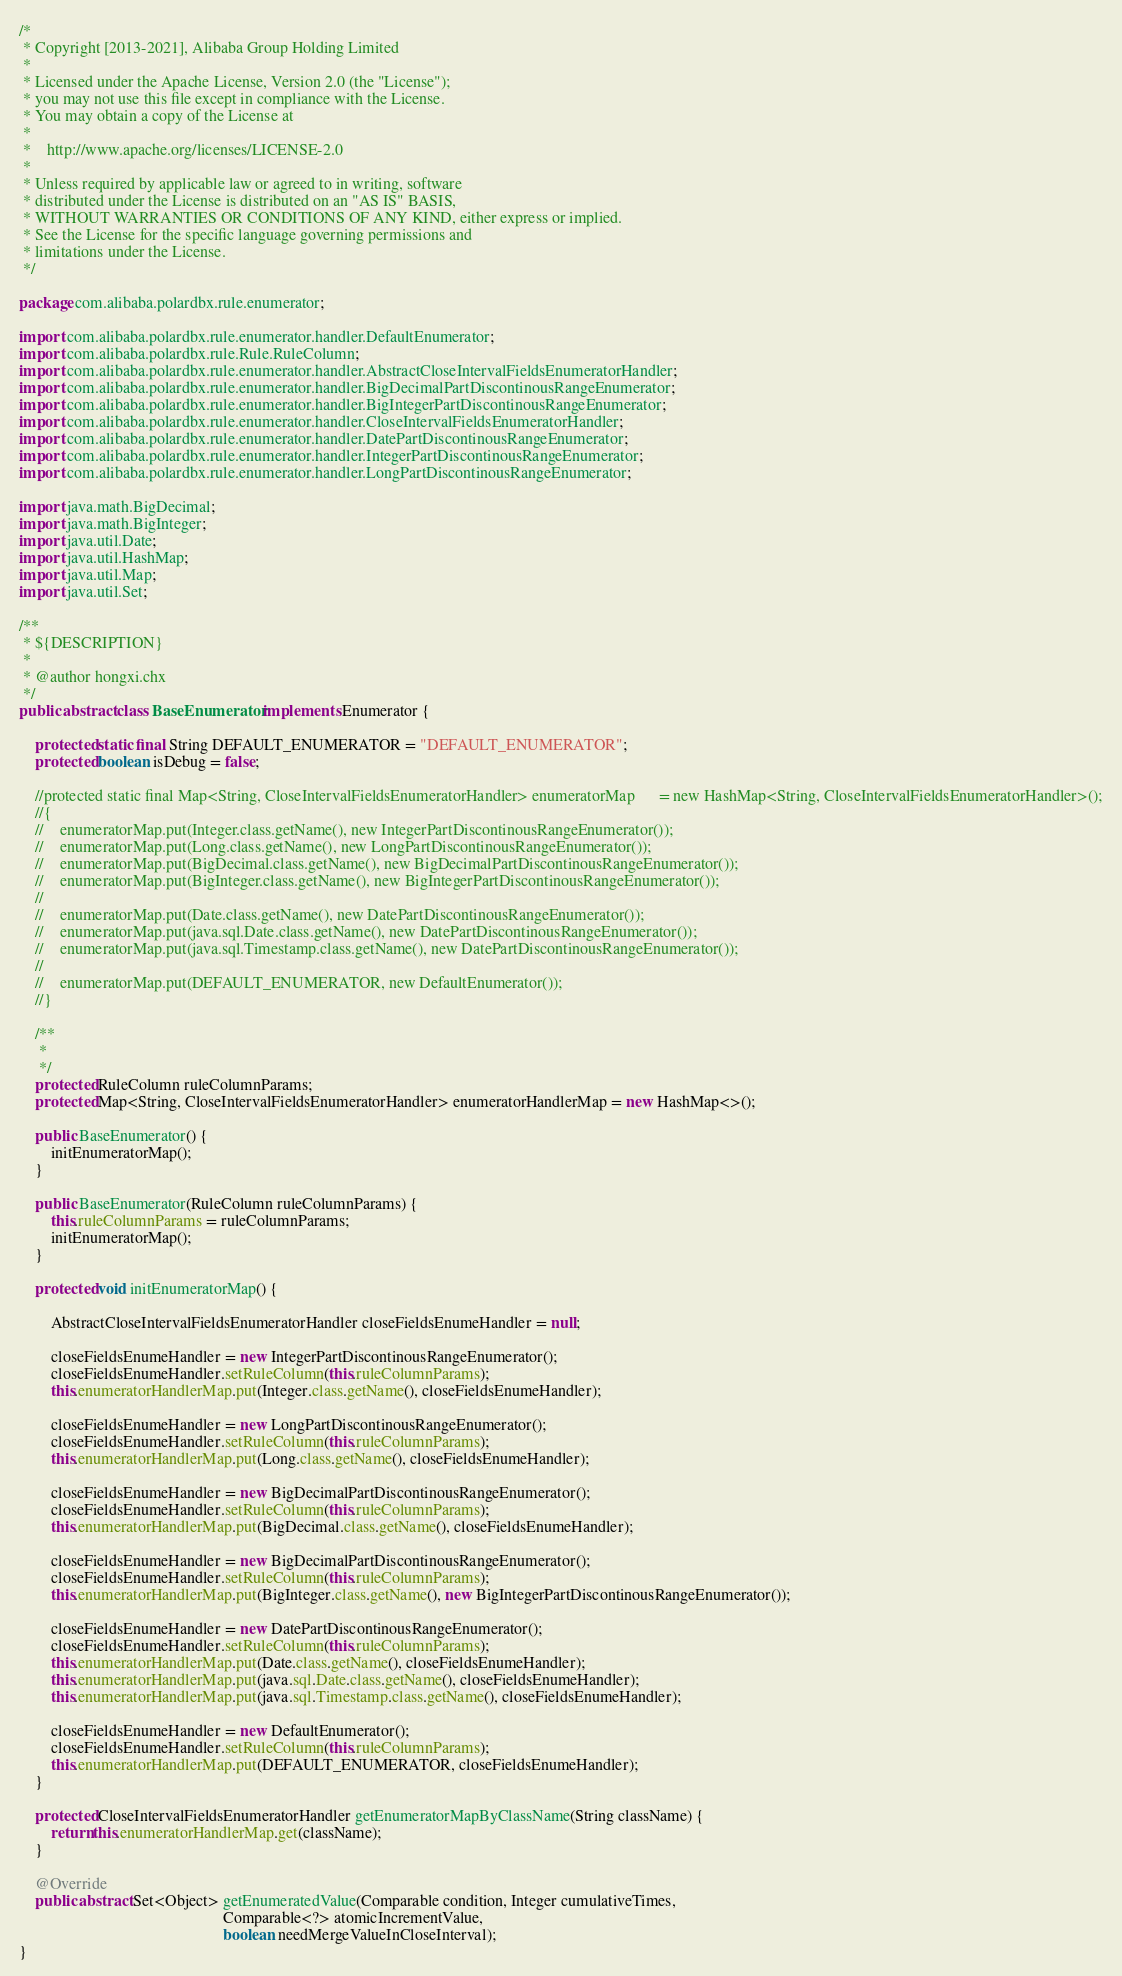Convert code to text. <code><loc_0><loc_0><loc_500><loc_500><_Java_>/*
 * Copyright [2013-2021], Alibaba Group Holding Limited
 *
 * Licensed under the Apache License, Version 2.0 (the "License");
 * you may not use this file except in compliance with the License.
 * You may obtain a copy of the License at
 *
 *    http://www.apache.org/licenses/LICENSE-2.0
 *
 * Unless required by applicable law or agreed to in writing, software
 * distributed under the License is distributed on an "AS IS" BASIS,
 * WITHOUT WARRANTIES OR CONDITIONS OF ANY KIND, either express or implied.
 * See the License for the specific language governing permissions and
 * limitations under the License.
 */

package com.alibaba.polardbx.rule.enumerator;

import com.alibaba.polardbx.rule.enumerator.handler.DefaultEnumerator;
import com.alibaba.polardbx.rule.Rule.RuleColumn;
import com.alibaba.polardbx.rule.enumerator.handler.AbstractCloseIntervalFieldsEnumeratorHandler;
import com.alibaba.polardbx.rule.enumerator.handler.BigDecimalPartDiscontinousRangeEnumerator;
import com.alibaba.polardbx.rule.enumerator.handler.BigIntegerPartDiscontinousRangeEnumerator;
import com.alibaba.polardbx.rule.enumerator.handler.CloseIntervalFieldsEnumeratorHandler;
import com.alibaba.polardbx.rule.enumerator.handler.DatePartDiscontinousRangeEnumerator;
import com.alibaba.polardbx.rule.enumerator.handler.IntegerPartDiscontinousRangeEnumerator;
import com.alibaba.polardbx.rule.enumerator.handler.LongPartDiscontinousRangeEnumerator;

import java.math.BigDecimal;
import java.math.BigInteger;
import java.util.Date;
import java.util.HashMap;
import java.util.Map;
import java.util.Set;

/**
 * ${DESCRIPTION}
 *
 * @author hongxi.chx
 */
public abstract class BaseEnumerator implements Enumerator {

    protected static final String DEFAULT_ENUMERATOR = "DEFAULT_ENUMERATOR";
    protected boolean isDebug = false;

    //protected static final Map<String, CloseIntervalFieldsEnumeratorHandler> enumeratorMap      = new HashMap<String, CloseIntervalFieldsEnumeratorHandler>();
    //{
    //    enumeratorMap.put(Integer.class.getName(), new IntegerPartDiscontinousRangeEnumerator());
    //    enumeratorMap.put(Long.class.getName(), new LongPartDiscontinousRangeEnumerator());
    //    enumeratorMap.put(BigDecimal.class.getName(), new BigDecimalPartDiscontinousRangeEnumerator());
    //    enumeratorMap.put(BigInteger.class.getName(), new BigIntegerPartDiscontinousRangeEnumerator());
    //
    //    enumeratorMap.put(Date.class.getName(), new DatePartDiscontinousRangeEnumerator());
    //    enumeratorMap.put(java.sql.Date.class.getName(), new DatePartDiscontinousRangeEnumerator());
    //    enumeratorMap.put(java.sql.Timestamp.class.getName(), new DatePartDiscontinousRangeEnumerator());
    //
    //    enumeratorMap.put(DEFAULT_ENUMERATOR, new DefaultEnumerator());
    //}

    /**
     *
     */
    protected RuleColumn ruleColumnParams;
    protected Map<String, CloseIntervalFieldsEnumeratorHandler> enumeratorHandlerMap = new HashMap<>();

    public BaseEnumerator() {
        initEnumeratorMap();
    }

    public BaseEnumerator(RuleColumn ruleColumnParams) {
        this.ruleColumnParams = ruleColumnParams;
        initEnumeratorMap();
    }

    protected void initEnumeratorMap() {

        AbstractCloseIntervalFieldsEnumeratorHandler closeFieldsEnumeHandler = null;

        closeFieldsEnumeHandler = new IntegerPartDiscontinousRangeEnumerator();
        closeFieldsEnumeHandler.setRuleColumn(this.ruleColumnParams);
        this.enumeratorHandlerMap.put(Integer.class.getName(), closeFieldsEnumeHandler);

        closeFieldsEnumeHandler = new LongPartDiscontinousRangeEnumerator();
        closeFieldsEnumeHandler.setRuleColumn(this.ruleColumnParams);
        this.enumeratorHandlerMap.put(Long.class.getName(), closeFieldsEnumeHandler);

        closeFieldsEnumeHandler = new BigDecimalPartDiscontinousRangeEnumerator();
        closeFieldsEnumeHandler.setRuleColumn(this.ruleColumnParams);
        this.enumeratorHandlerMap.put(BigDecimal.class.getName(), closeFieldsEnumeHandler);

        closeFieldsEnumeHandler = new BigDecimalPartDiscontinousRangeEnumerator();
        closeFieldsEnumeHandler.setRuleColumn(this.ruleColumnParams);
        this.enumeratorHandlerMap.put(BigInteger.class.getName(), new BigIntegerPartDiscontinousRangeEnumerator());

        closeFieldsEnumeHandler = new DatePartDiscontinousRangeEnumerator();
        closeFieldsEnumeHandler.setRuleColumn(this.ruleColumnParams);
        this.enumeratorHandlerMap.put(Date.class.getName(), closeFieldsEnumeHandler);
        this.enumeratorHandlerMap.put(java.sql.Date.class.getName(), closeFieldsEnumeHandler);
        this.enumeratorHandlerMap.put(java.sql.Timestamp.class.getName(), closeFieldsEnumeHandler);

        closeFieldsEnumeHandler = new DefaultEnumerator();
        closeFieldsEnumeHandler.setRuleColumn(this.ruleColumnParams);
        this.enumeratorHandlerMap.put(DEFAULT_ENUMERATOR, closeFieldsEnumeHandler);
    }

    protected CloseIntervalFieldsEnumeratorHandler getEnumeratorMapByClassName(String className) {
        return this.enumeratorHandlerMap.get(className);
    }

    @Override
    public abstract Set<Object> getEnumeratedValue(Comparable condition, Integer cumulativeTimes,
                                                   Comparable<?> atomicIncrementValue,
                                                   boolean needMergeValueInCloseInterval);
}
</code> 